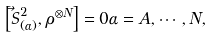Convert formula to latex. <formula><loc_0><loc_0><loc_500><loc_500>\left [ \vec { S } ^ { 2 } _ { ( \alpha ) } , \rho ^ { \otimes N } \right ] = 0 \alpha = A , \cdots , N ,</formula> 